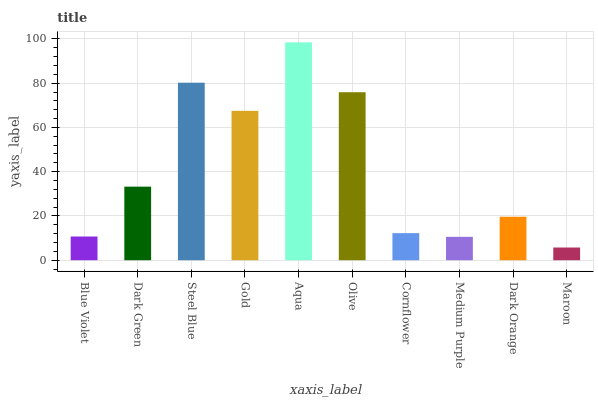Is Maroon the minimum?
Answer yes or no. Yes. Is Aqua the maximum?
Answer yes or no. Yes. Is Dark Green the minimum?
Answer yes or no. No. Is Dark Green the maximum?
Answer yes or no. No. Is Dark Green greater than Blue Violet?
Answer yes or no. Yes. Is Blue Violet less than Dark Green?
Answer yes or no. Yes. Is Blue Violet greater than Dark Green?
Answer yes or no. No. Is Dark Green less than Blue Violet?
Answer yes or no. No. Is Dark Green the high median?
Answer yes or no. Yes. Is Dark Orange the low median?
Answer yes or no. Yes. Is Aqua the high median?
Answer yes or no. No. Is Maroon the low median?
Answer yes or no. No. 